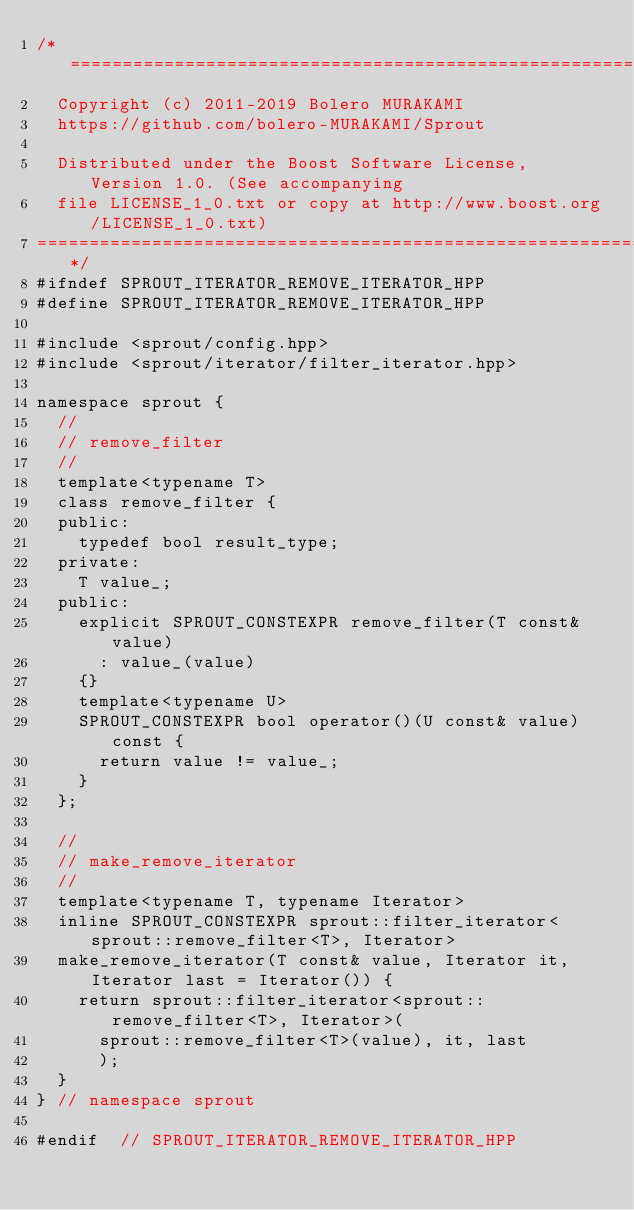Convert code to text. <code><loc_0><loc_0><loc_500><loc_500><_C++_>/*=============================================================================
  Copyright (c) 2011-2019 Bolero MURAKAMI
  https://github.com/bolero-MURAKAMI/Sprout

  Distributed under the Boost Software License, Version 1.0. (See accompanying
  file LICENSE_1_0.txt or copy at http://www.boost.org/LICENSE_1_0.txt)
=============================================================================*/
#ifndef SPROUT_ITERATOR_REMOVE_ITERATOR_HPP
#define SPROUT_ITERATOR_REMOVE_ITERATOR_HPP

#include <sprout/config.hpp>
#include <sprout/iterator/filter_iterator.hpp>

namespace sprout {
	//
	// remove_filter
	//
	template<typename T>
	class remove_filter {
	public:
		typedef bool result_type;
	private:
		T value_;
	public:
		explicit SPROUT_CONSTEXPR remove_filter(T const& value)
			: value_(value)
		{}
		template<typename U>
		SPROUT_CONSTEXPR bool operator()(U const& value) const {
			return value != value_;
		}
	};

	//
	// make_remove_iterator
	//
	template<typename T, typename Iterator>
	inline SPROUT_CONSTEXPR sprout::filter_iterator<sprout::remove_filter<T>, Iterator>
	make_remove_iterator(T const& value, Iterator it, Iterator last = Iterator()) {
		return sprout::filter_iterator<sprout::remove_filter<T>, Iterator>(
			sprout::remove_filter<T>(value), it, last
			);
	}
}	// namespace sprout

#endif	// SPROUT_ITERATOR_REMOVE_ITERATOR_HPP
</code> 